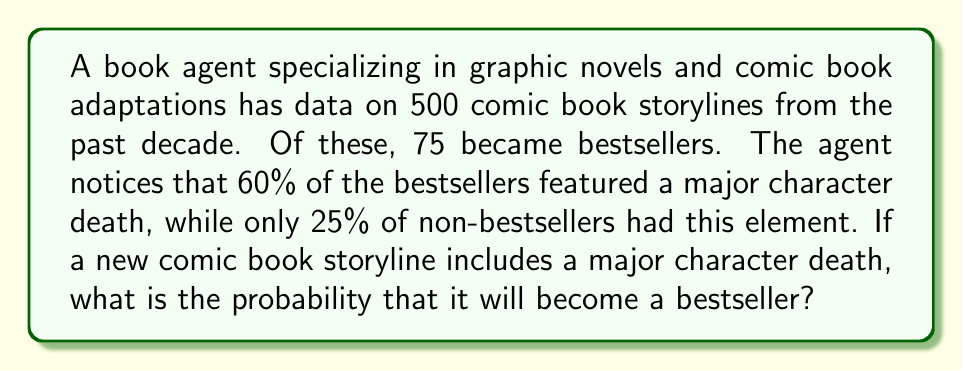Could you help me with this problem? To solve this problem, we'll use Bayes' theorem. Let's define our events:

A: The comic book becomes a bestseller
B: The comic book features a major character death

We need to find P(A|B), which is the probability of becoming a bestseller given that there's a major character death.

Bayes' theorem states:

$$ P(A|B) = \frac{P(B|A) \cdot P(A)}{P(B)} $$

From the given information:
1. P(A) = 75/500 = 0.15 (probability of becoming a bestseller)
2. P(B|A) = 0.60 (60% of bestsellers feature a major character death)
3. P(B) = P(B|A) · P(A) + P(B|not A) · P(not A)

We need to calculate P(B):
P(not A) = 1 - P(A) = 1 - 0.15 = 0.85
P(B|not A) = 0.25 (25% of non-bestsellers feature a major character death)

$$ P(B) = 0.60 \cdot 0.15 + 0.25 \cdot 0.85 = 0.09 + 0.2125 = 0.3025 $$

Now we can apply Bayes' theorem:

$$ P(A|B) = \frac{0.60 \cdot 0.15}{0.3025} = \frac{0.09}{0.3025} \approx 0.2975 $$
Answer: The probability that a new comic book storyline with a major character death will become a bestseller is approximately 0.2975 or 29.75%. 